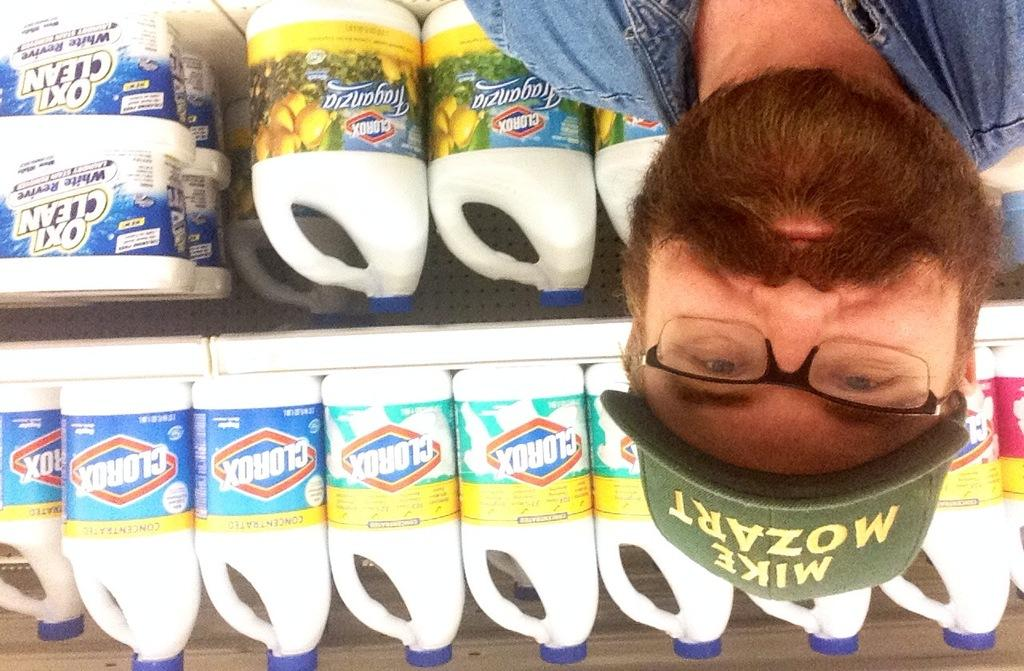What can be seen in the image? There is a person in the image. Can you describe the person's appearance? The person is wearing spectacles and a cap. What is visible behind the person? There are boxes and bottles in racks behind the person. Is there a rabbit wearing an umbrella in the image? No, there is no rabbit or umbrella present in the image. 